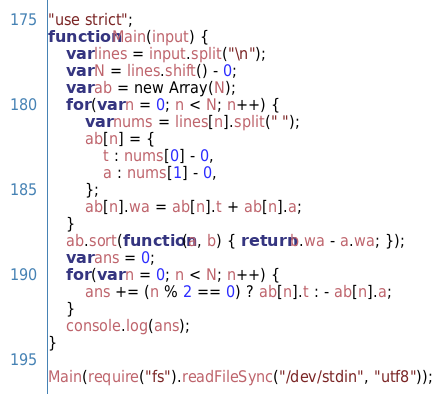<code> <loc_0><loc_0><loc_500><loc_500><_JavaScript_>"use strict";
function Main(input) {
    var lines = input.split("\n");
    var N = lines.shift() - 0;
    var ab = new Array(N);
    for (var n = 0; n < N; n++) {
        var nums = lines[n].split(" ");
        ab[n] = {
            t : nums[0] - 0,
            a : nums[1] - 0,
        };
        ab[n].wa = ab[n].t + ab[n].a;
    }
    ab.sort(function(a, b) { return b.wa - a.wa; });
    var ans = 0;
    for (var n = 0; n < N; n++) {
        ans += (n % 2 == 0) ? ab[n].t : - ab[n].a;
    }
    console.log(ans);
}

Main(require("fs").readFileSync("/dev/stdin", "utf8"));
</code> 